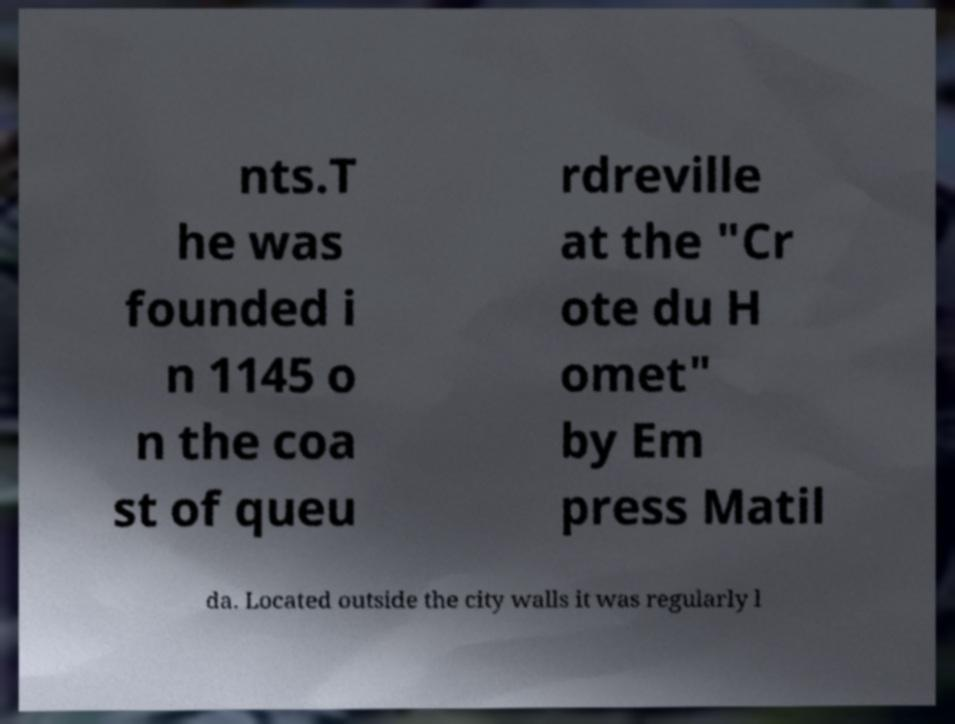Could you extract and type out the text from this image? nts.T he was founded i n 1145 o n the coa st of queu rdreville at the "Cr ote du H omet" by Em press Matil da. Located outside the city walls it was regularly l 